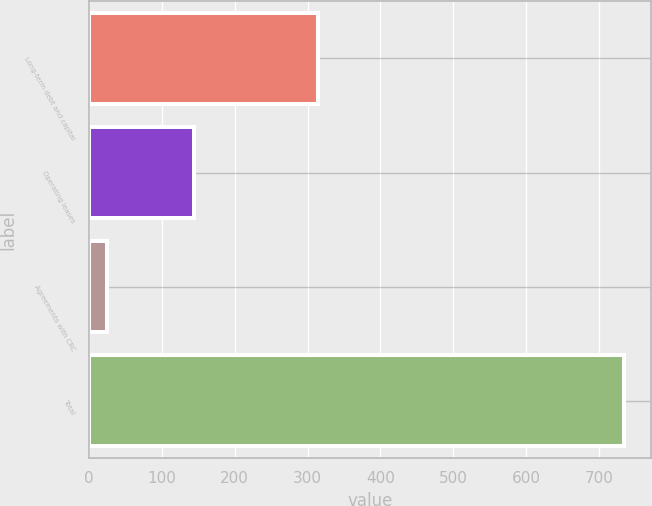Convert chart. <chart><loc_0><loc_0><loc_500><loc_500><bar_chart><fcel>Long-term debt and capital<fcel>Operating leases<fcel>Agreements with CRC<fcel>Total<nl><fcel>314<fcel>144<fcel>25<fcel>734<nl></chart> 